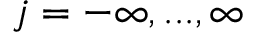<formula> <loc_0><loc_0><loc_500><loc_500>j = - \infty , \dots , \infty</formula> 